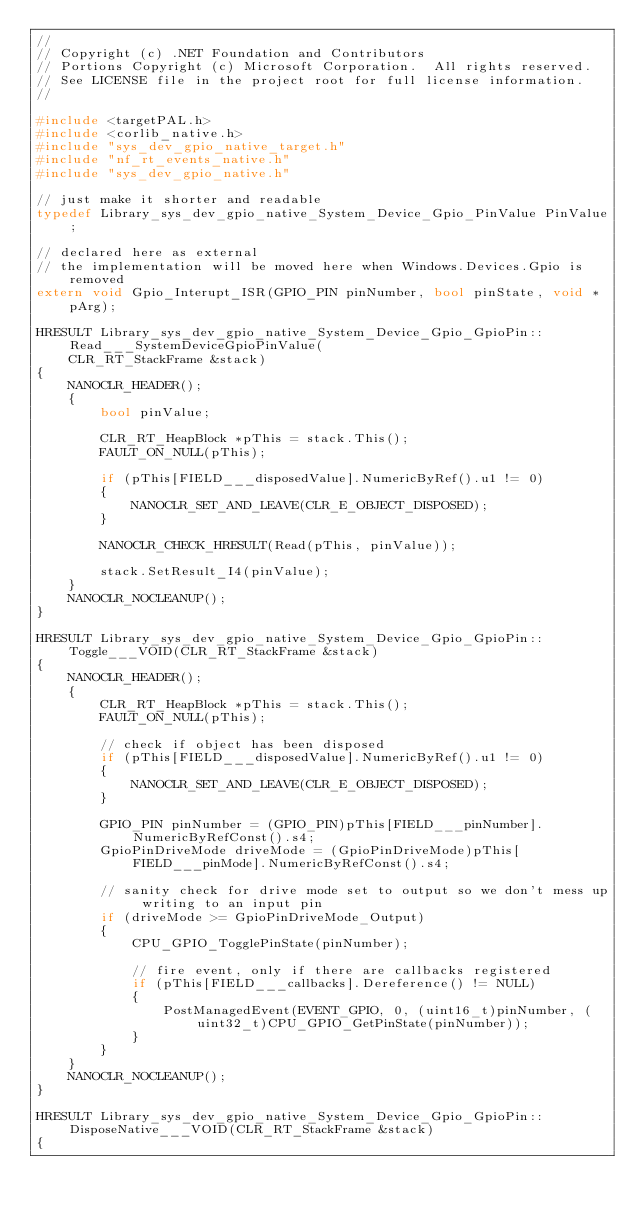Convert code to text. <code><loc_0><loc_0><loc_500><loc_500><_C++_>//
// Copyright (c) .NET Foundation and Contributors
// Portions Copyright (c) Microsoft Corporation.  All rights reserved.
// See LICENSE file in the project root for full license information.
//

#include <targetPAL.h>
#include <corlib_native.h>
#include "sys_dev_gpio_native_target.h"
#include "nf_rt_events_native.h"
#include "sys_dev_gpio_native.h"

// just make it shorter and readable
typedef Library_sys_dev_gpio_native_System_Device_Gpio_PinValue PinValue;

// declared here as external
// the implementation will be moved here when Windows.Devices.Gpio is removed
extern void Gpio_Interupt_ISR(GPIO_PIN pinNumber, bool pinState, void *pArg);

HRESULT Library_sys_dev_gpio_native_System_Device_Gpio_GpioPin::Read___SystemDeviceGpioPinValue(
    CLR_RT_StackFrame &stack)
{
    NANOCLR_HEADER();
    {
        bool pinValue;

        CLR_RT_HeapBlock *pThis = stack.This();
        FAULT_ON_NULL(pThis);

        if (pThis[FIELD___disposedValue].NumericByRef().u1 != 0)
        {
            NANOCLR_SET_AND_LEAVE(CLR_E_OBJECT_DISPOSED);
        }

        NANOCLR_CHECK_HRESULT(Read(pThis, pinValue));

        stack.SetResult_I4(pinValue);
    }
    NANOCLR_NOCLEANUP();
}

HRESULT Library_sys_dev_gpio_native_System_Device_Gpio_GpioPin::Toggle___VOID(CLR_RT_StackFrame &stack)
{
    NANOCLR_HEADER();
    {
        CLR_RT_HeapBlock *pThis = stack.This();
        FAULT_ON_NULL(pThis);

        // check if object has been disposed
        if (pThis[FIELD___disposedValue].NumericByRef().u1 != 0)
        {
            NANOCLR_SET_AND_LEAVE(CLR_E_OBJECT_DISPOSED);
        }

        GPIO_PIN pinNumber = (GPIO_PIN)pThis[FIELD___pinNumber].NumericByRefConst().s4;
        GpioPinDriveMode driveMode = (GpioPinDriveMode)pThis[FIELD___pinMode].NumericByRefConst().s4;

        // sanity check for drive mode set to output so we don't mess up writing to an input pin
        if (driveMode >= GpioPinDriveMode_Output)
        {
            CPU_GPIO_TogglePinState(pinNumber);

            // fire event, only if there are callbacks registered
            if (pThis[FIELD___callbacks].Dereference() != NULL)
            {
                PostManagedEvent(EVENT_GPIO, 0, (uint16_t)pinNumber, (uint32_t)CPU_GPIO_GetPinState(pinNumber));
            }
        }
    }
    NANOCLR_NOCLEANUP();
}

HRESULT Library_sys_dev_gpio_native_System_Device_Gpio_GpioPin::DisposeNative___VOID(CLR_RT_StackFrame &stack)
{</code> 